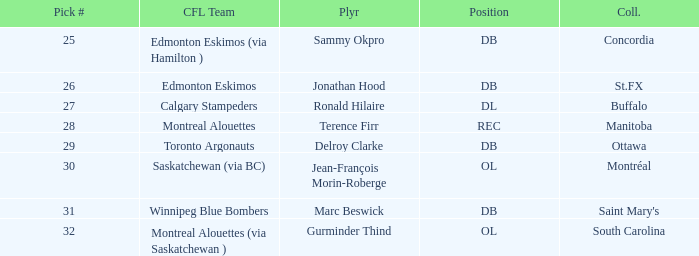What is buffalo's pick #? 27.0. 